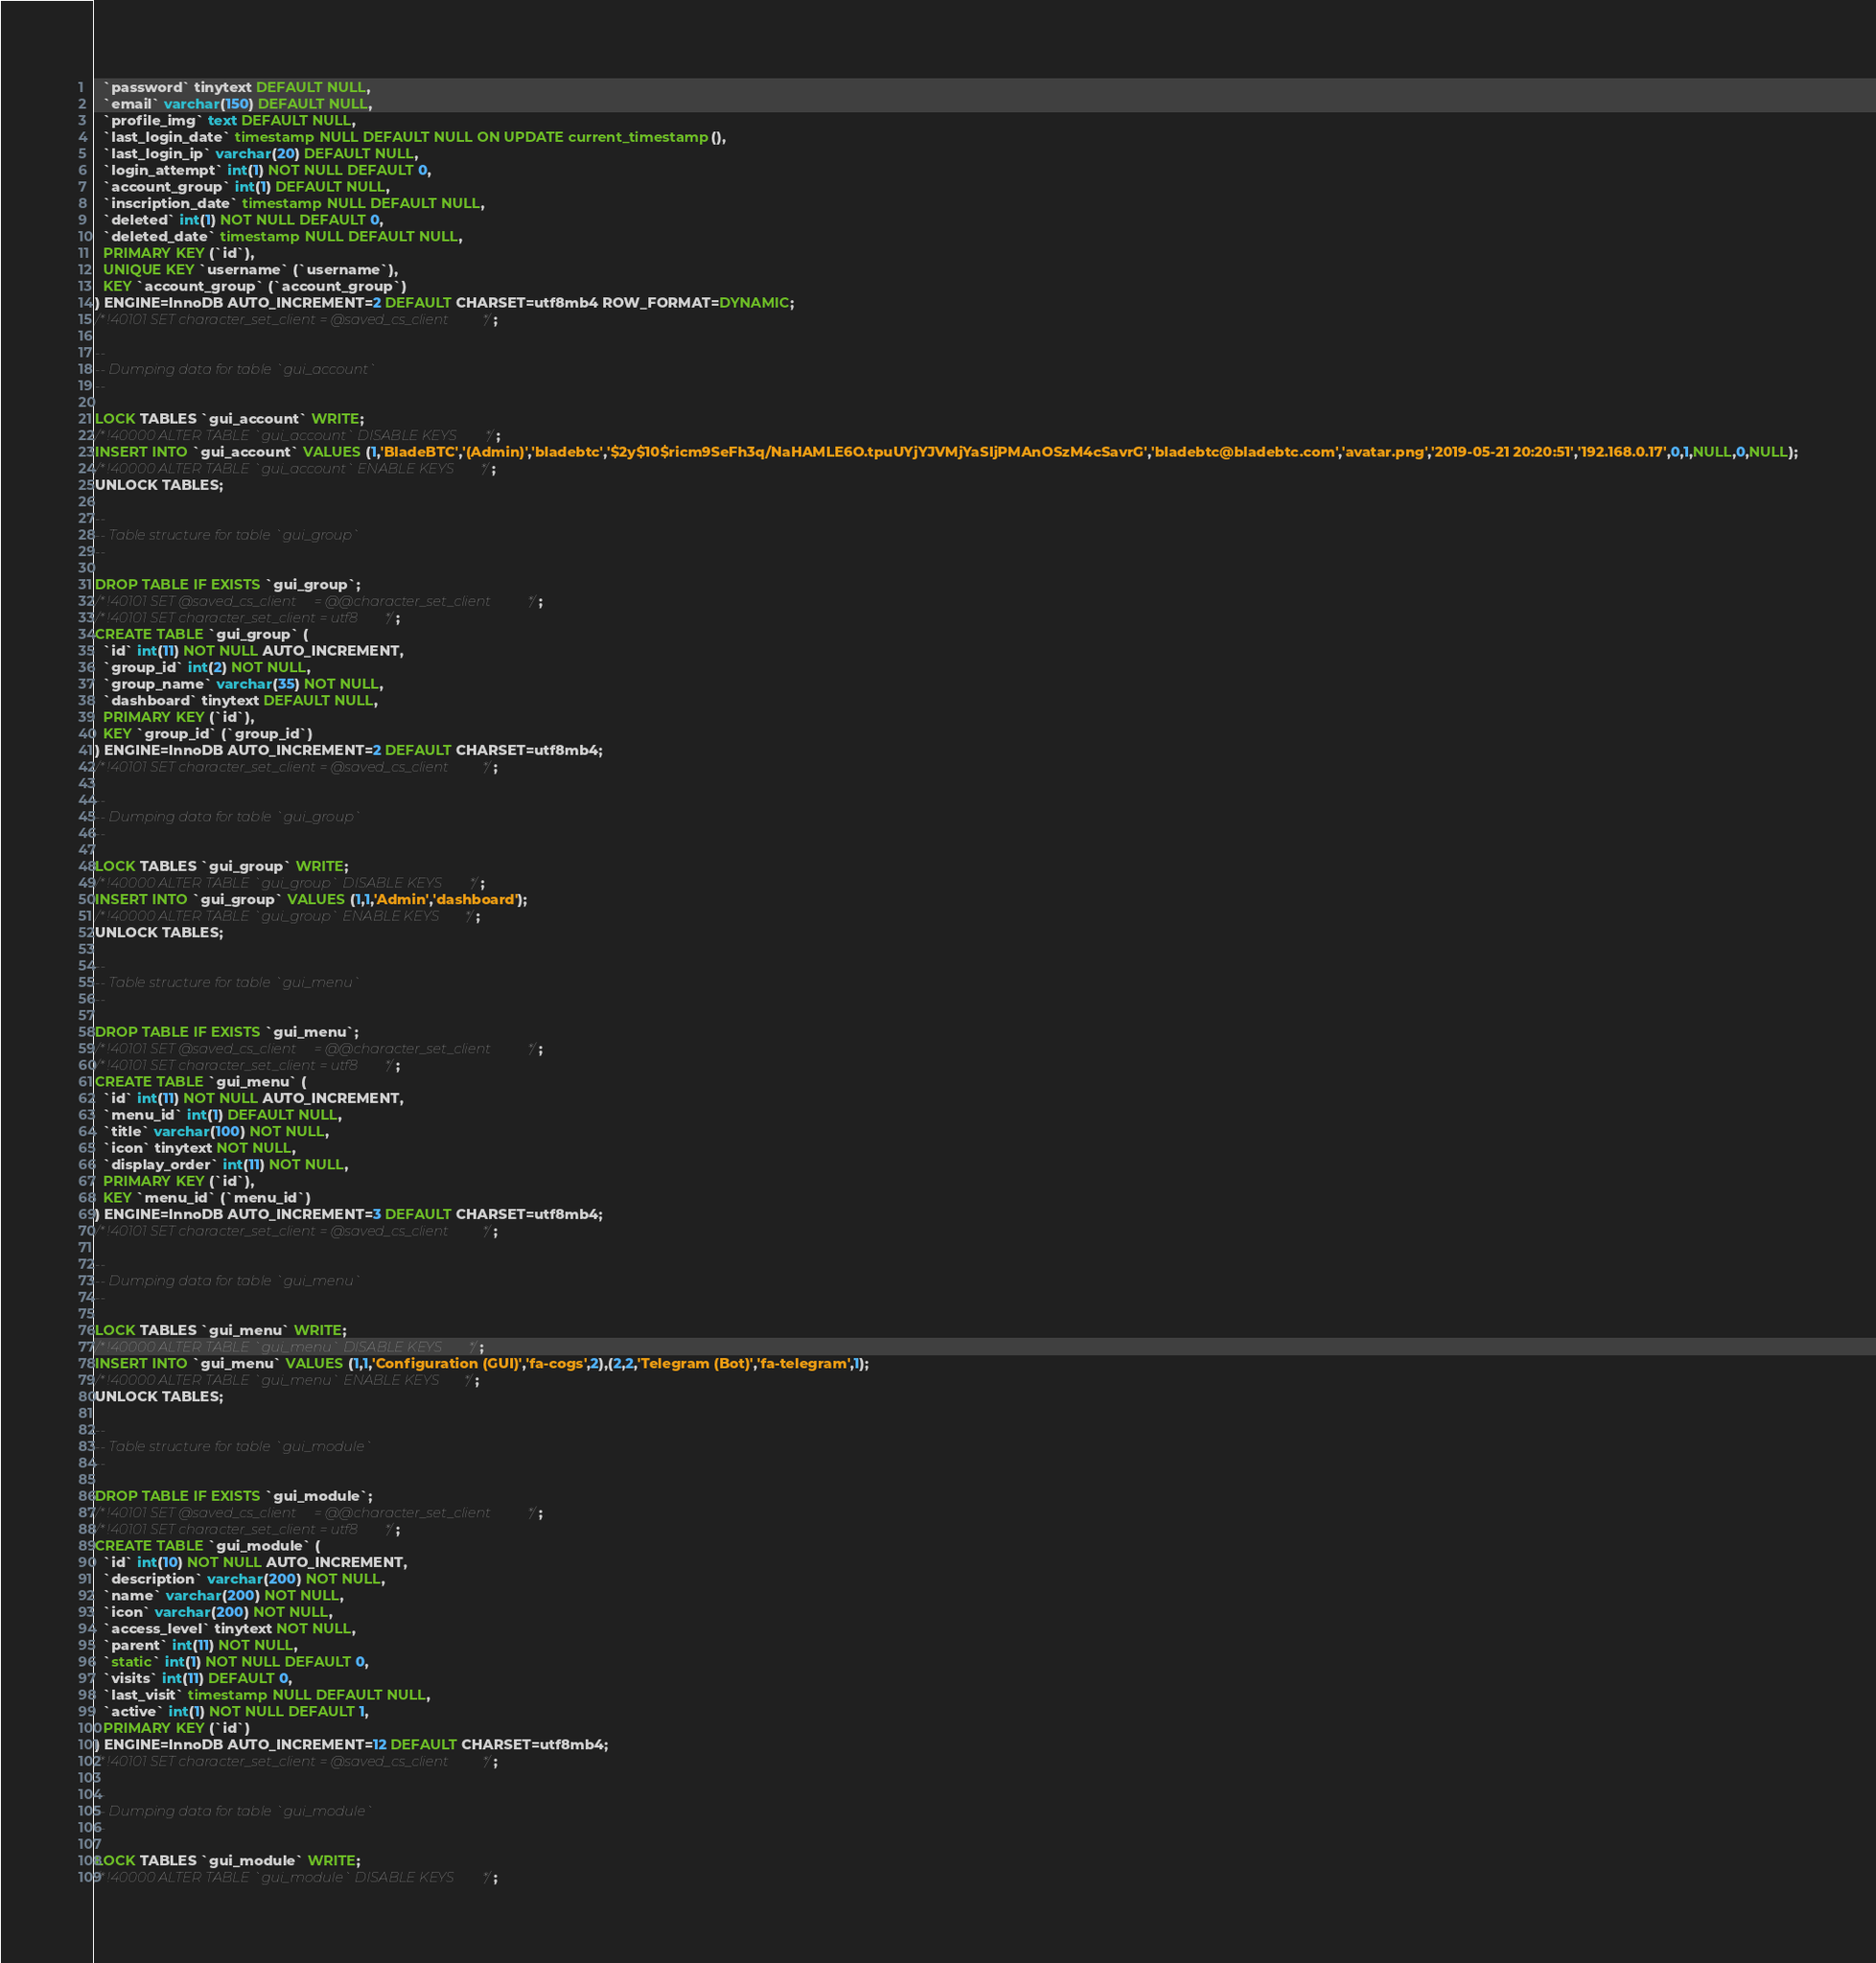Convert code to text. <code><loc_0><loc_0><loc_500><loc_500><_SQL_>  `password` tinytext DEFAULT NULL,
  `email` varchar(150) DEFAULT NULL,
  `profile_img` text DEFAULT NULL,
  `last_login_date` timestamp NULL DEFAULT NULL ON UPDATE current_timestamp(),
  `last_login_ip` varchar(20) DEFAULT NULL,
  `login_attempt` int(1) NOT NULL DEFAULT 0,
  `account_group` int(1) DEFAULT NULL,
  `inscription_date` timestamp NULL DEFAULT NULL,
  `deleted` int(1) NOT NULL DEFAULT 0,
  `deleted_date` timestamp NULL DEFAULT NULL,
  PRIMARY KEY (`id`),
  UNIQUE KEY `username` (`username`),
  KEY `account_group` (`account_group`)
) ENGINE=InnoDB AUTO_INCREMENT=2 DEFAULT CHARSET=utf8mb4 ROW_FORMAT=DYNAMIC;
/*!40101 SET character_set_client = @saved_cs_client */;

--
-- Dumping data for table `gui_account`
--

LOCK TABLES `gui_account` WRITE;
/*!40000 ALTER TABLE `gui_account` DISABLE KEYS */;
INSERT INTO `gui_account` VALUES (1,'BladeBTC','(Admin)','bladebtc','$2y$10$ricm9SeFh3q/NaHAMLE6O.tpuUYjYJVMjYaSIjPMAnOSzM4cSavrG','bladebtc@bladebtc.com','avatar.png','2019-05-21 20:20:51','192.168.0.17',0,1,NULL,0,NULL);
/*!40000 ALTER TABLE `gui_account` ENABLE KEYS */;
UNLOCK TABLES;

--
-- Table structure for table `gui_group`
--

DROP TABLE IF EXISTS `gui_group`;
/*!40101 SET @saved_cs_client     = @@character_set_client */;
/*!40101 SET character_set_client = utf8 */;
CREATE TABLE `gui_group` (
  `id` int(11) NOT NULL AUTO_INCREMENT,
  `group_id` int(2) NOT NULL,
  `group_name` varchar(35) NOT NULL,
  `dashboard` tinytext DEFAULT NULL,
  PRIMARY KEY (`id`),
  KEY `group_id` (`group_id`)
) ENGINE=InnoDB AUTO_INCREMENT=2 DEFAULT CHARSET=utf8mb4;
/*!40101 SET character_set_client = @saved_cs_client */;

--
-- Dumping data for table `gui_group`
--

LOCK TABLES `gui_group` WRITE;
/*!40000 ALTER TABLE `gui_group` DISABLE KEYS */;
INSERT INTO `gui_group` VALUES (1,1,'Admin','dashboard');
/*!40000 ALTER TABLE `gui_group` ENABLE KEYS */;
UNLOCK TABLES;

--
-- Table structure for table `gui_menu`
--

DROP TABLE IF EXISTS `gui_menu`;
/*!40101 SET @saved_cs_client     = @@character_set_client */;
/*!40101 SET character_set_client = utf8 */;
CREATE TABLE `gui_menu` (
  `id` int(11) NOT NULL AUTO_INCREMENT,
  `menu_id` int(1) DEFAULT NULL,
  `title` varchar(100) NOT NULL,
  `icon` tinytext NOT NULL,
  `display_order` int(11) NOT NULL,
  PRIMARY KEY (`id`),
  KEY `menu_id` (`menu_id`)
) ENGINE=InnoDB AUTO_INCREMENT=3 DEFAULT CHARSET=utf8mb4;
/*!40101 SET character_set_client = @saved_cs_client */;

--
-- Dumping data for table `gui_menu`
--

LOCK TABLES `gui_menu` WRITE;
/*!40000 ALTER TABLE `gui_menu` DISABLE KEYS */;
INSERT INTO `gui_menu` VALUES (1,1,'Configuration (GUI)','fa-cogs',2),(2,2,'Telegram (Bot)','fa-telegram',1);
/*!40000 ALTER TABLE `gui_menu` ENABLE KEYS */;
UNLOCK TABLES;

--
-- Table structure for table `gui_module`
--

DROP TABLE IF EXISTS `gui_module`;
/*!40101 SET @saved_cs_client     = @@character_set_client */;
/*!40101 SET character_set_client = utf8 */;
CREATE TABLE `gui_module` (
  `id` int(10) NOT NULL AUTO_INCREMENT,
  `description` varchar(200) NOT NULL,
  `name` varchar(200) NOT NULL,
  `icon` varchar(200) NOT NULL,
  `access_level` tinytext NOT NULL,
  `parent` int(11) NOT NULL,
  `static` int(1) NOT NULL DEFAULT 0,
  `visits` int(11) DEFAULT 0,
  `last_visit` timestamp NULL DEFAULT NULL,
  `active` int(1) NOT NULL DEFAULT 1,
  PRIMARY KEY (`id`)
) ENGINE=InnoDB AUTO_INCREMENT=12 DEFAULT CHARSET=utf8mb4;
/*!40101 SET character_set_client = @saved_cs_client */;

--
-- Dumping data for table `gui_module`
--

LOCK TABLES `gui_module` WRITE;
/*!40000 ALTER TABLE `gui_module` DISABLE KEYS */;</code> 